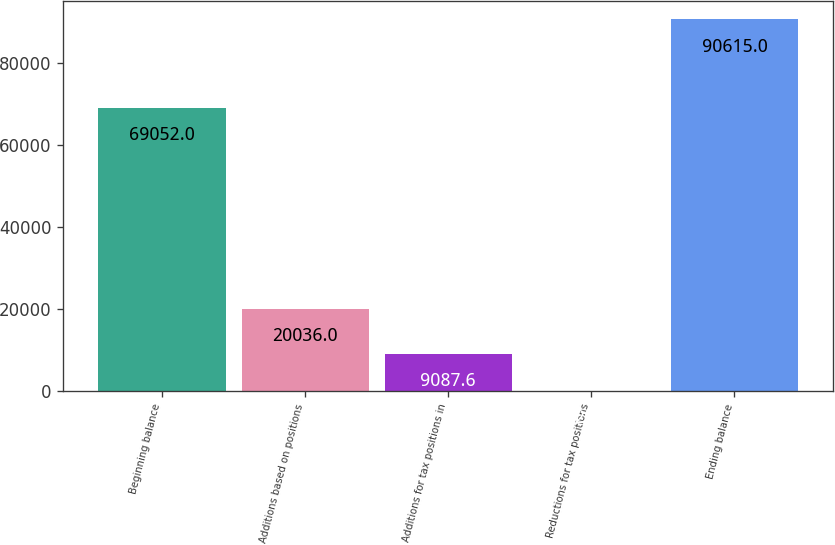Convert chart. <chart><loc_0><loc_0><loc_500><loc_500><bar_chart><fcel>Beginning balance<fcel>Additions based on positions<fcel>Additions for tax positions in<fcel>Reductions for tax positions<fcel>Ending balance<nl><fcel>69052<fcel>20036<fcel>9087.6<fcel>29<fcel>90615<nl></chart> 